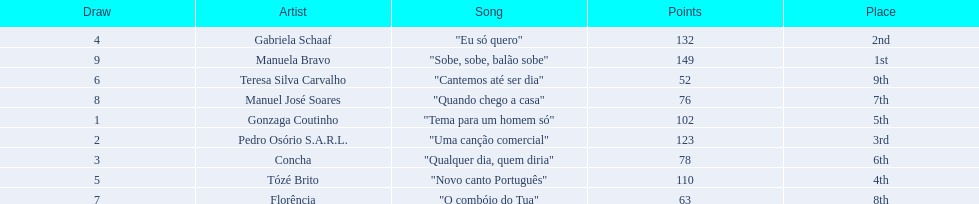Which artists sang in the eurovision song contest of 1979? Gonzaga Coutinho, Pedro Osório S.A.R.L., Concha, Gabriela Schaaf, Tózé Brito, Teresa Silva Carvalho, Florência, Manuel José Soares, Manuela Bravo. Of these, who sang eu so quero? Gabriela Schaaf. 